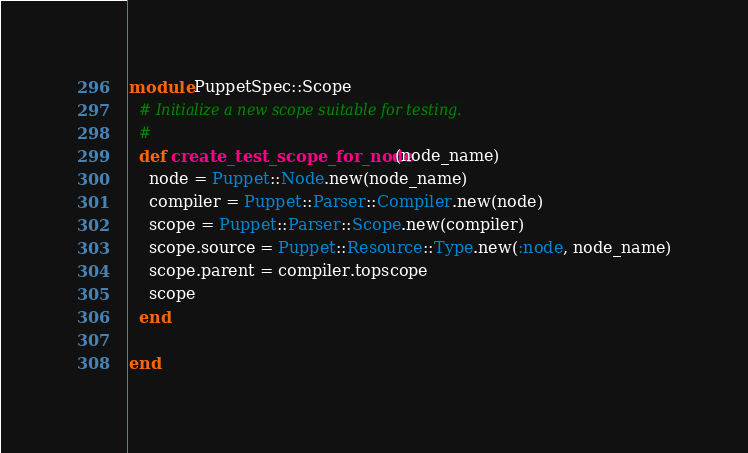Convert code to text. <code><loc_0><loc_0><loc_500><loc_500><_Ruby_>module PuppetSpec::Scope
  # Initialize a new scope suitable for testing.
  #
  def create_test_scope_for_node(node_name)
    node = Puppet::Node.new(node_name)
    compiler = Puppet::Parser::Compiler.new(node)
    scope = Puppet::Parser::Scope.new(compiler)
    scope.source = Puppet::Resource::Type.new(:node, node_name)
    scope.parent = compiler.topscope
    scope
  end

end
</code> 